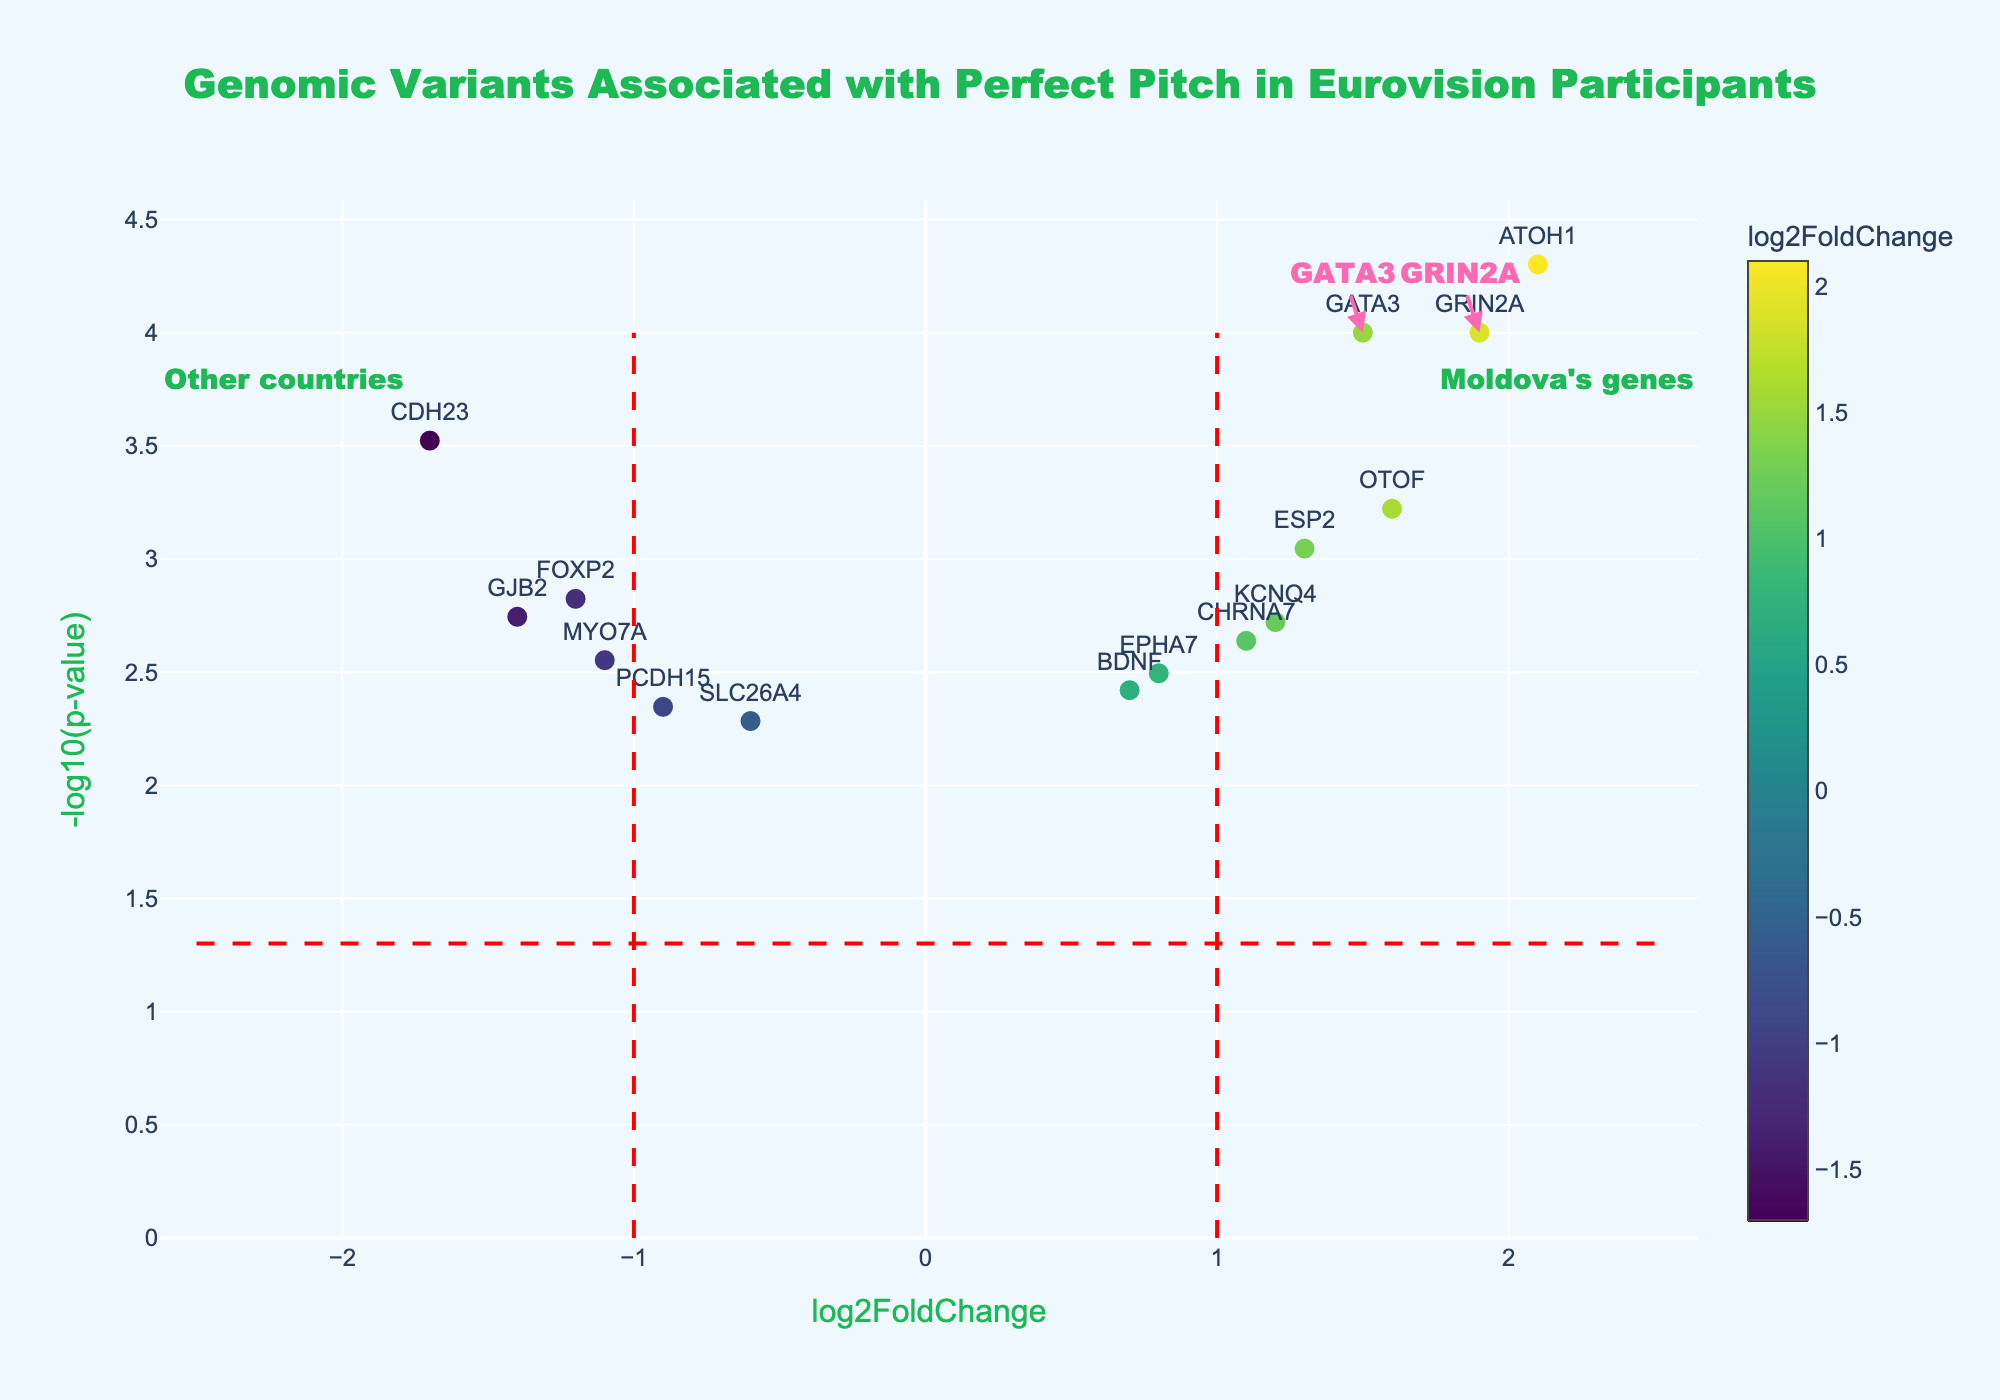What is the title of the plot? The title of the plot is displayed at the top of the figure, usually in a larger and bolder font. It summarizes the content of the plot.
Answer: Genomic Variants Associated with Perfect Pitch in Eurovision Participants Which gene from Moldova has the highest log2FoldChange? To identify the gene from Moldova with the highest log2FoldChange, locate the points annotated as Moldova's genes on the plot and compare their x-axis values. The one farthest to the right has the highest log2FoldChange.
Answer: GRIN2A How many genes have a log2FoldChange greater than 1? Count the number of data points that are positioned to the right of the vertical line at log2FoldChange = 1.
Answer: 5 What is the log2FoldChange and p-value of the gene GATA3 from Moldova? Find the point labeled GATA3 on the plot. The x-axis value is the log2FoldChange and the y-axis value is the -log10(p-value). Convert -log10(p-value) back to p-value.
Answer: log2FoldChange: 1.5, p-value: 0.0001 Which gene has the lowest p-value on the plot? The gene with the lowest p-value will have the highest -log10(p-value) value on the y-axis. Locate the highest point on the plot and identify the gene label.
Answer: ATOH1 Compare the log2FoldChange of CHRNA7 from Ukraine to that of OTOF from Russia. Which one is greater? Find the data points labeled CHRNA7 (Ukraine) and OTOF (Russia) on the plot, then compare their x-axis values to determine which one is greater.
Answer: OTOF On which side of the vertical line at log2FoldChange = 0 do most genes from countries other than Moldova fall? Observe the distribution of data points from countries other than Moldova and determine whether more of them are on the left side (negative log2FoldChange) or the right side (positive log2FoldChange) of the vertical line at log2FoldChange = 0.
Answer: Right side Determine the average log2FoldChange for genes from Moldova. Identify the log2FoldChange values for the genes from Moldova (GATA3 and GRIN2A). Calculate the average by summing the values and then dividing by the number of genes.
Answer: 1.7 Which country has a gene with a log2FoldChange close to -1.4? Locate the data point at or near x = -1.4 on the plot, then check the corresponding country from the hover information.
Answer: Spain 